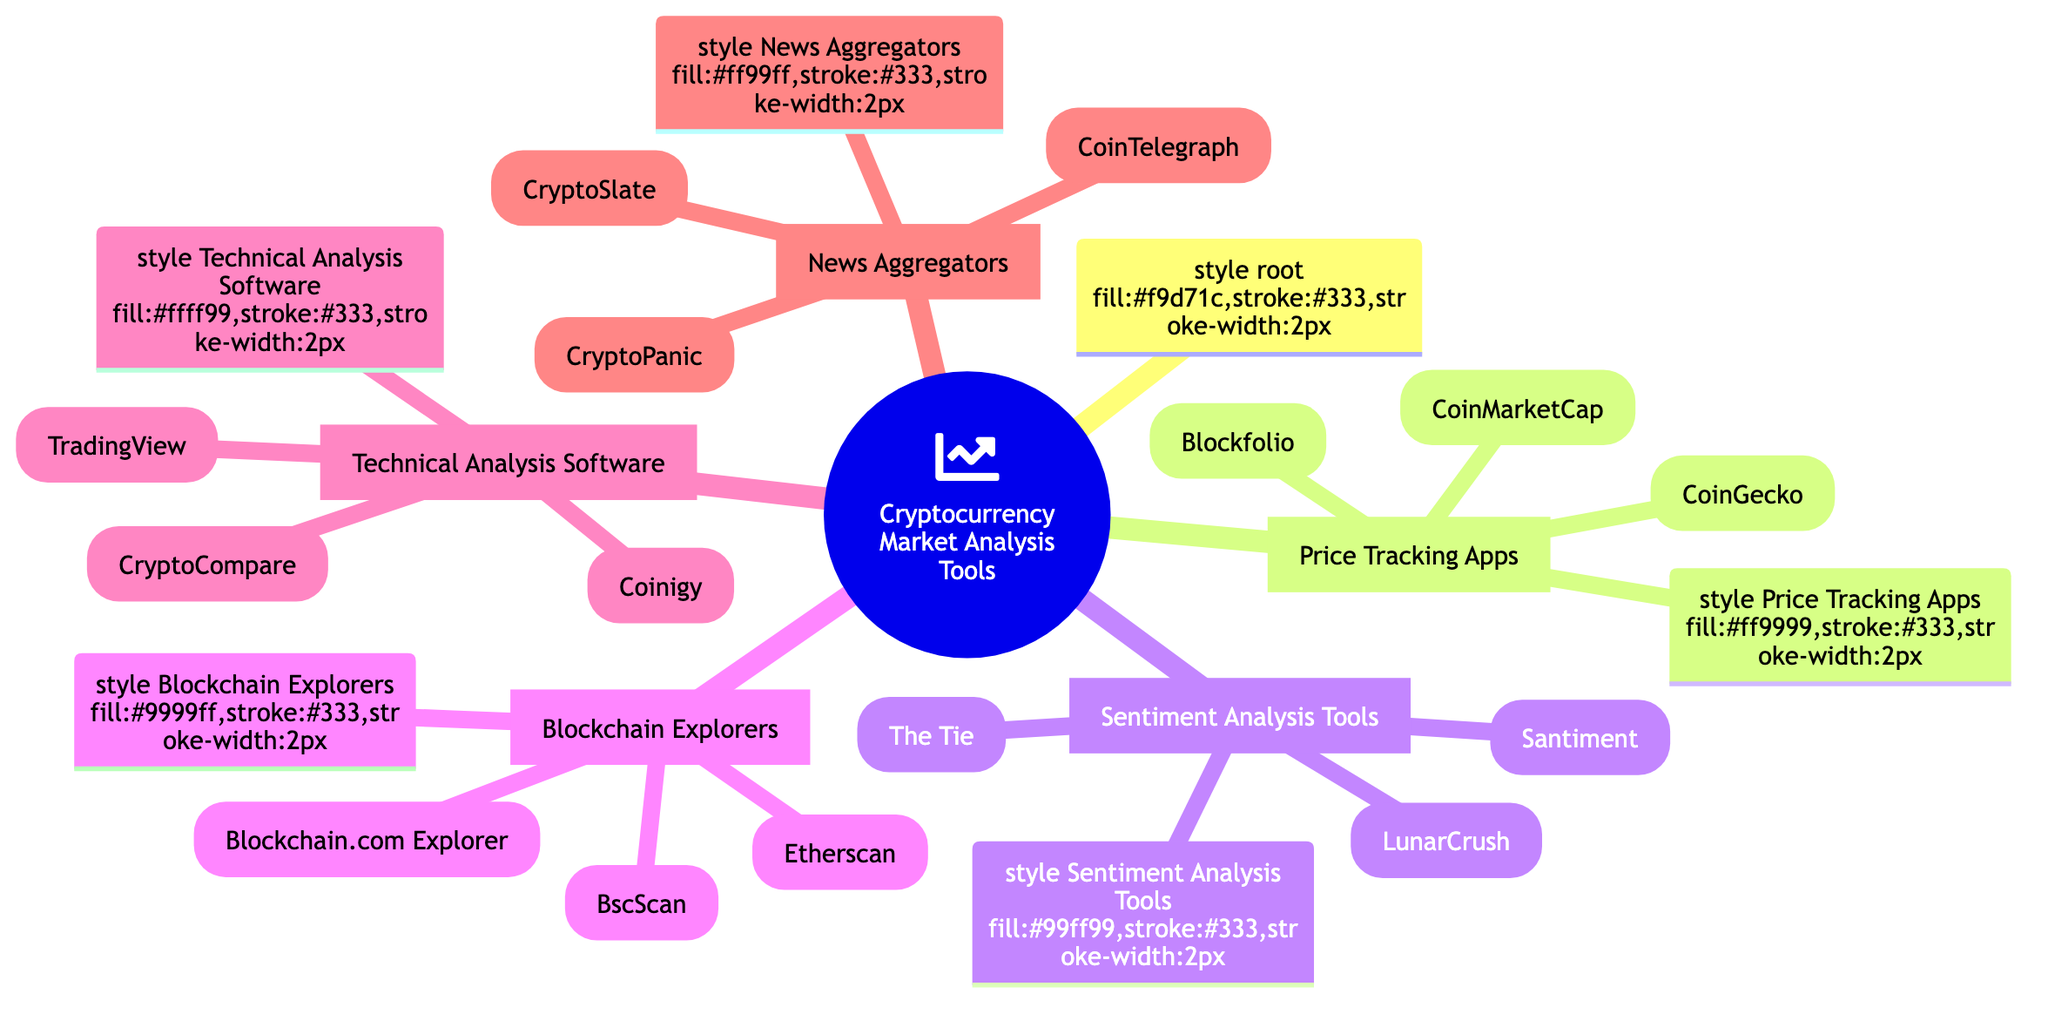What are the three categories of tools identified in the mind map? The mind map has five main categories, which are Price Tracking Apps, Sentiment Analysis Tools, Blockchain Explorers, Technical Analysis Software, and News Aggregators.
Answer: Price Tracking Apps, Sentiment Analysis Tools, Blockchain Explorers, Technical Analysis Software, News Aggregators How many tools are listed under News Aggregators? In the News Aggregators category, there are three specific tools: CryptoPanic, CoinTelegraph, and CryptoSlate.
Answer: Three Which tool provides advanced charting tools? The Technical Analysis Software category includes TradingView, which is specifically described as a web-based platform that provides advanced charting tools and analytical capabilities.
Answer: TradingView What is the function of Blockfolio? Blockfolio is a mobile app aimed at tracking the performance of cryptocurrency investments, as indicated in the Price Tracking Apps section.
Answer: Tracking performance How many tools are specified under Sentiment Analysis Tools? The Sentiment Analysis Tools category lists three individual tools: LunarCrush, Santiment, and The Tie. Therefore, the total count of tools in this category is three.
Answer: Three Which blockchain explorer is specifically for the Ethereum network? Etherscan is identified in the Blockchain Explorers section as a blockchain explorer designed specifically for the Ethereum network, allowing users to track transactions and wallet balances.
Answer: Etherscan What type of information does Santiment analyze? Santiment provides market and sentiment analysis using a combination of on-chain, social, and development information as indicated in the Sentiment Analysis Tools section.
Answer: On-chain, social, and development information Which category includes CoinTelegraph? CoinTelegraph is categorized under News Aggregators, which serves as a major cryptocurrency news site that provides updates and analysis.
Answer: News Aggregators Which tool integrates with multiple exchanges? Coinigy is listed under Technical Analysis Software and is noted for providing an array of technical analysis tools while integrating with multiple exchanges.
Answer: Coinigy 